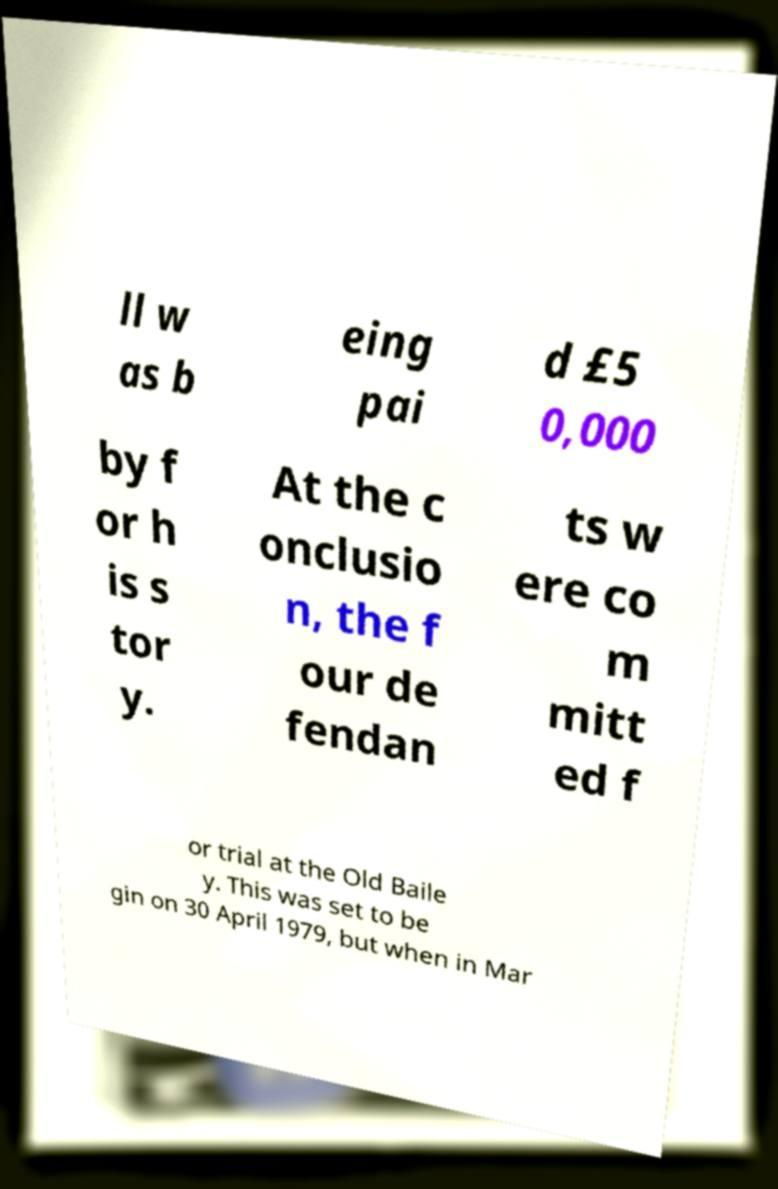Can you read and provide the text displayed in the image?This photo seems to have some interesting text. Can you extract and type it out for me? ll w as b eing pai d £5 0,000 by f or h is s tor y. At the c onclusio n, the f our de fendan ts w ere co m mitt ed f or trial at the Old Baile y. This was set to be gin on 30 April 1979, but when in Mar 